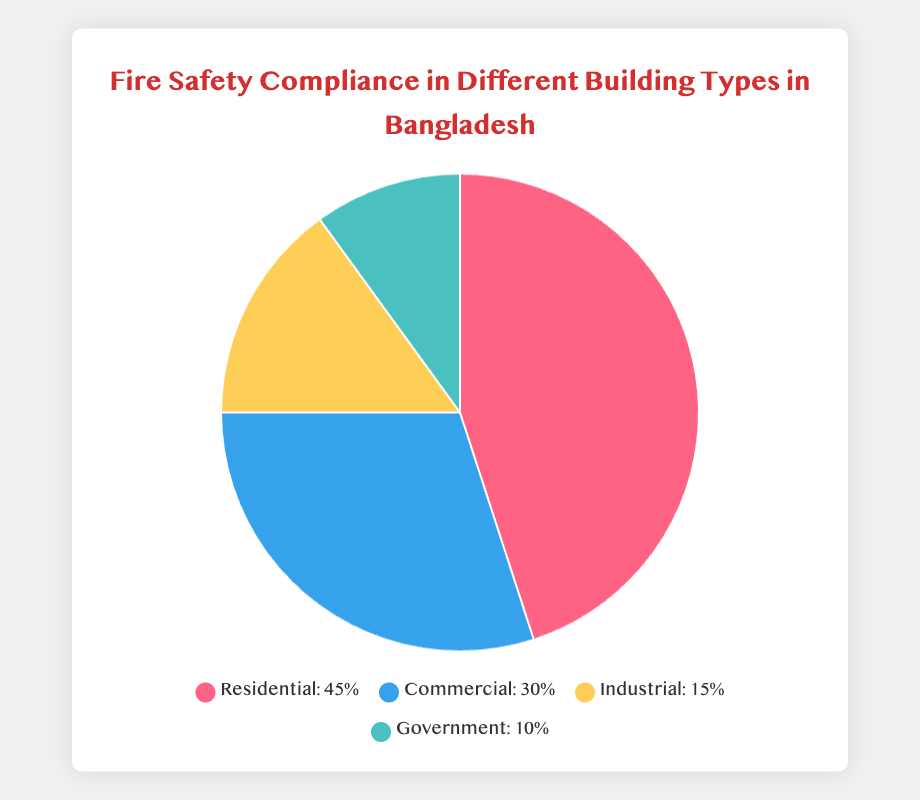What percentage of buildings comply with fire safety regulations in Residential and Commercial categories combined? To find the combined compliance percentage for Residential and Commercial buildings, add their individual percentages: 45% (Residential) + 30% (Commercial) = 75%.
Answer: 75% Which type of building has the lowest fire safety compliance percentage? By comparing the percentages visually, Government buildings have the lowest compliance at 10%.
Answer: Government How much higher is the compliance percentage for Residential buildings compared to Industrial buildings? Subtract the compliance percentage of Industrial buildings from Residential buildings: 45% (Residential) - 15% (Industrial) = 30%.
Answer: 30% What is the difference in compliance percentage between the building type with the highest compliance and the type with the lowest compliance? Subtract the lowest compliance percentage (Government) from the highest compliance percentage (Residential): 45% (Residential) - 10% (Government) = 35%.
Answer: 35% How many types of buildings have a compliance rate below 20%? By visually inspecting the chart, Industrial (15%) and Government (10%) buildings have compliance rates below 20%, so there are 2 such types.
Answer: 2 Which building type is represented by the color yellow in the pie chart? The color yellow represents the "Industrial" building type based on the visual attribute of the chart.
Answer: Industrial Rank the building types in ascending order of their fire safety compliance percentages. By comparing the compliance percentages visually: Government (10%) < Industrial (15%) < Commercial (30%) < Residential (45%).
Answer: Government, Industrial, Commercial, Residential What fraction of the compliance rate of Commercial buildings does Industrial buildings have? To find the fraction, divide the compliance percentage of Industrial buildings by that of Commercial buildings: 15% (Industrial) / 30% (Commercial) = 0.5 or 1/2.
Answer: 1/2 By what percentage does the total compliance rate for Government and Industrial buildings fall short of the compliance rate for Residential buildings? Add the compliance percentages for Government and Industrial buildings: 10% + 15% = 25%. Subtract this total from the Residential building percentage: 45% - 25% = 20%.
Answer: 20% 